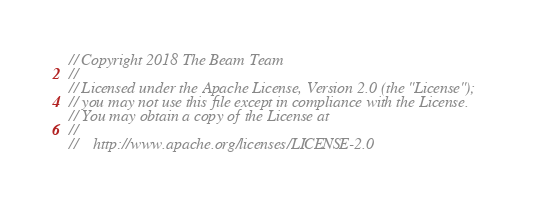Convert code to text. <code><loc_0><loc_0><loc_500><loc_500><_C++_>// Copyright 2018 The Beam Team
//
// Licensed under the Apache License, Version 2.0 (the "License");
// you may not use this file except in compliance with the License.
// You may obtain a copy of the License at
//
//    http://www.apache.org/licenses/LICENSE-2.0</code> 